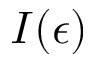Convert formula to latex. <formula><loc_0><loc_0><loc_500><loc_500>I ( \epsilon )</formula> 